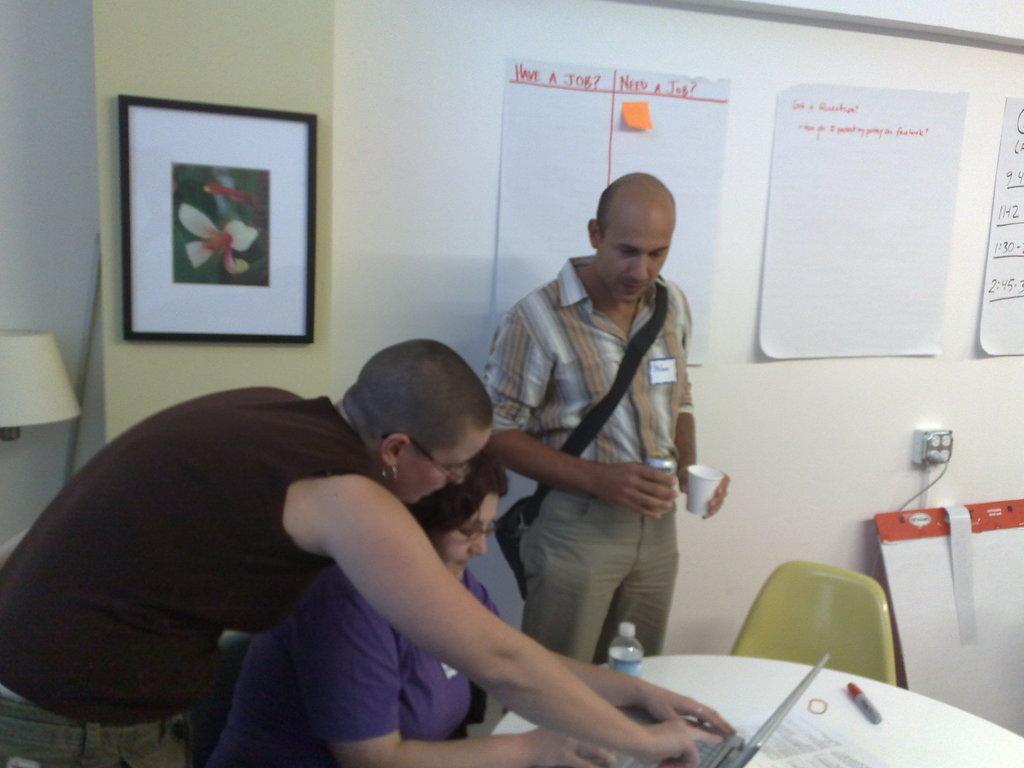How would you summarize this image in a sentence or two? On the left side of the image a lady is bending. In the center of the image a lady is sitting and operating laptop. In the center of the image a man is standing and wearing bag and holding cups in his hands. In the background of the image we can see board, papers, photo frame, wall, lamp, chair, socket are there. At the bottom of the image there is a table. On the table we can see marker, paper, laptop, bottle are there. 